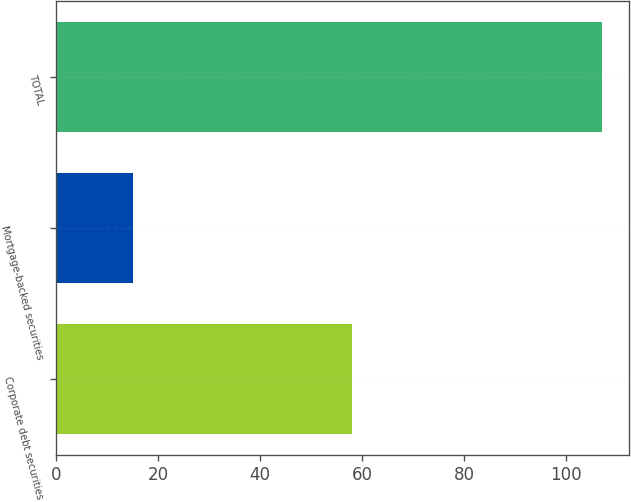<chart> <loc_0><loc_0><loc_500><loc_500><bar_chart><fcel>Corporate debt securities<fcel>Mortgage-backed securities<fcel>TOTAL<nl><fcel>58<fcel>15<fcel>107<nl></chart> 